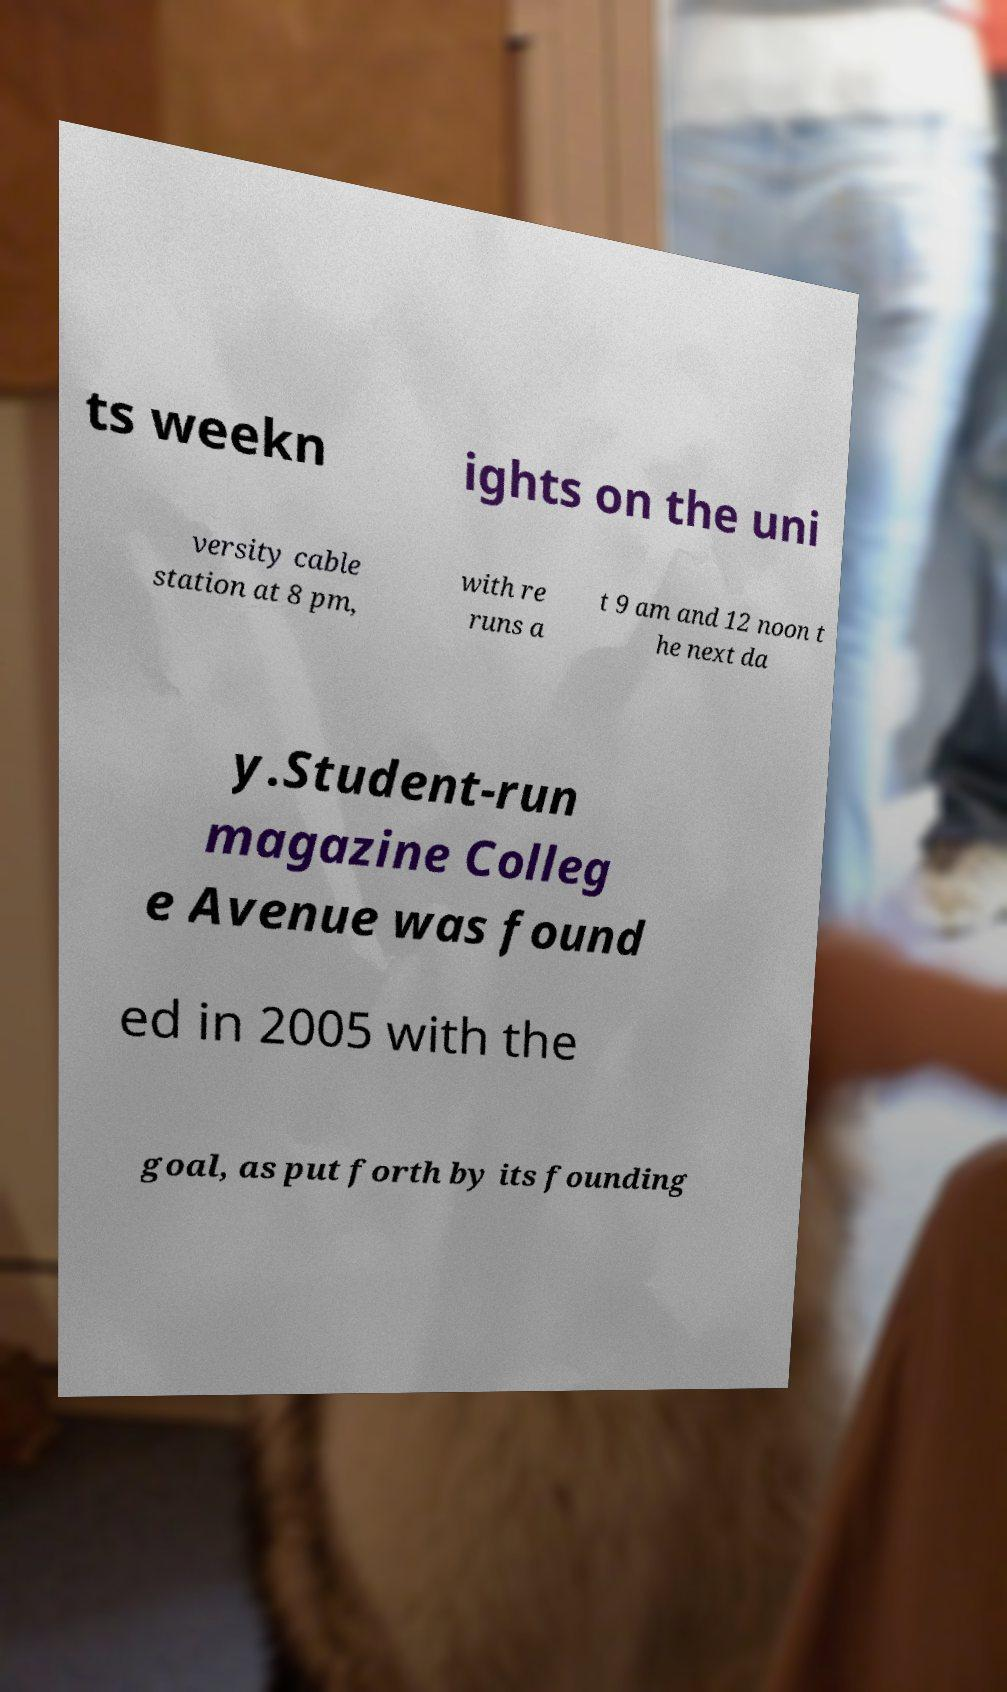I need the written content from this picture converted into text. Can you do that? ts weekn ights on the uni versity cable station at 8 pm, with re runs a t 9 am and 12 noon t he next da y.Student-run magazine Colleg e Avenue was found ed in 2005 with the goal, as put forth by its founding 